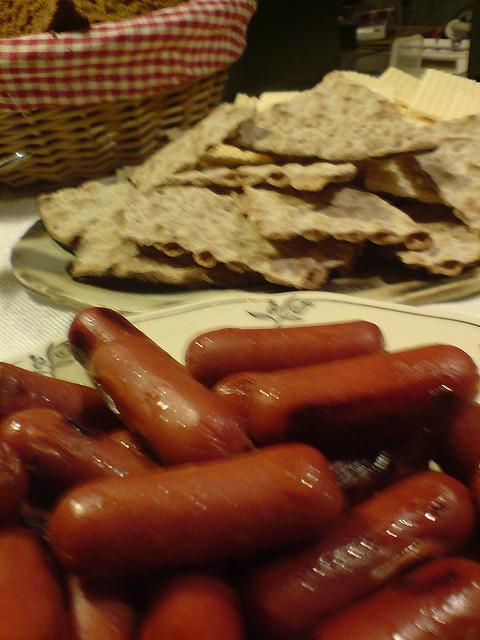How many hot dogs can you see?
Give a very brief answer. 12. 